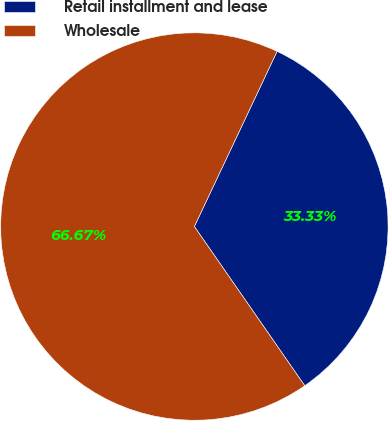Convert chart to OTSL. <chart><loc_0><loc_0><loc_500><loc_500><pie_chart><fcel>Retail installment and lease<fcel>Wholesale<nl><fcel>33.33%<fcel>66.67%<nl></chart> 